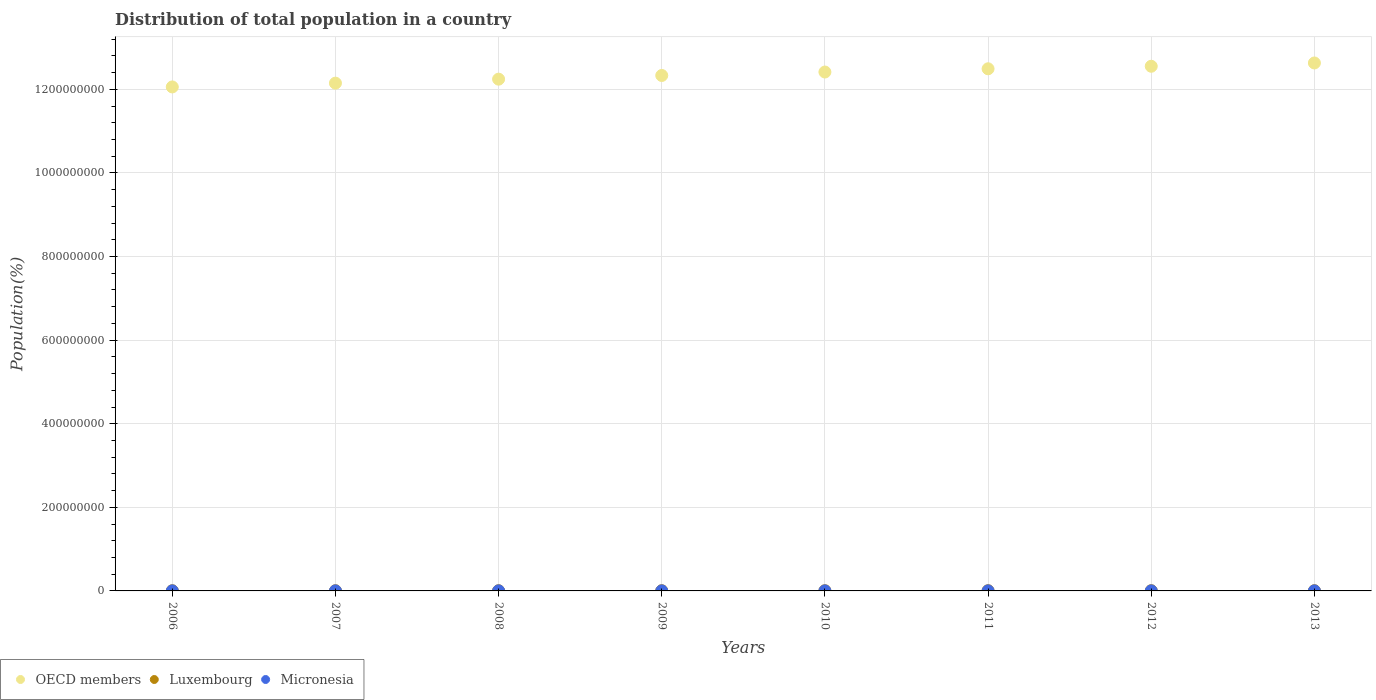How many different coloured dotlines are there?
Your answer should be compact. 3. What is the population of in Micronesia in 2007?
Your answer should be very brief. 1.05e+05. Across all years, what is the maximum population of in Luxembourg?
Your response must be concise. 5.43e+05. Across all years, what is the minimum population of in Micronesia?
Make the answer very short. 1.03e+05. What is the total population of in OECD members in the graph?
Provide a short and direct response. 9.89e+09. What is the difference between the population of in Luxembourg in 2008 and that in 2013?
Offer a very short reply. -5.47e+04. What is the difference between the population of in Micronesia in 2012 and the population of in OECD members in 2008?
Give a very brief answer. -1.22e+09. What is the average population of in Luxembourg per year?
Your answer should be very brief. 5.05e+05. In the year 2011, what is the difference between the population of in Micronesia and population of in OECD members?
Ensure brevity in your answer.  -1.25e+09. In how many years, is the population of in OECD members greater than 120000000 %?
Provide a short and direct response. 8. What is the ratio of the population of in Luxembourg in 2006 to that in 2011?
Offer a terse response. 0.91. What is the difference between the highest and the second highest population of in OECD members?
Give a very brief answer. 7.88e+06. What is the difference between the highest and the lowest population of in Micronesia?
Make the answer very short. 2204. Is the population of in OECD members strictly greater than the population of in Micronesia over the years?
Your answer should be compact. Yes. Is the population of in OECD members strictly less than the population of in Micronesia over the years?
Your answer should be compact. No. How many dotlines are there?
Your response must be concise. 3. Does the graph contain grids?
Your response must be concise. Yes. What is the title of the graph?
Make the answer very short. Distribution of total population in a country. Does "Haiti" appear as one of the legend labels in the graph?
Offer a very short reply. No. What is the label or title of the Y-axis?
Offer a very short reply. Population(%). What is the Population(%) in OECD members in 2006?
Make the answer very short. 1.21e+09. What is the Population(%) of Luxembourg in 2006?
Your answer should be very brief. 4.73e+05. What is the Population(%) of Micronesia in 2006?
Give a very brief answer. 1.06e+05. What is the Population(%) in OECD members in 2007?
Your answer should be very brief. 1.21e+09. What is the Population(%) of Luxembourg in 2007?
Your answer should be very brief. 4.80e+05. What is the Population(%) of Micronesia in 2007?
Offer a terse response. 1.05e+05. What is the Population(%) of OECD members in 2008?
Provide a succinct answer. 1.22e+09. What is the Population(%) in Luxembourg in 2008?
Your response must be concise. 4.89e+05. What is the Population(%) in Micronesia in 2008?
Your answer should be compact. 1.04e+05. What is the Population(%) of OECD members in 2009?
Ensure brevity in your answer.  1.23e+09. What is the Population(%) in Luxembourg in 2009?
Keep it short and to the point. 4.98e+05. What is the Population(%) of Micronesia in 2009?
Your response must be concise. 1.04e+05. What is the Population(%) of OECD members in 2010?
Ensure brevity in your answer.  1.24e+09. What is the Population(%) in Luxembourg in 2010?
Keep it short and to the point. 5.07e+05. What is the Population(%) in Micronesia in 2010?
Keep it short and to the point. 1.04e+05. What is the Population(%) of OECD members in 2011?
Offer a very short reply. 1.25e+09. What is the Population(%) of Luxembourg in 2011?
Provide a succinct answer. 5.18e+05. What is the Population(%) in Micronesia in 2011?
Ensure brevity in your answer.  1.03e+05. What is the Population(%) in OECD members in 2012?
Give a very brief answer. 1.26e+09. What is the Population(%) in Luxembourg in 2012?
Keep it short and to the point. 5.31e+05. What is the Population(%) of Micronesia in 2012?
Give a very brief answer. 1.04e+05. What is the Population(%) of OECD members in 2013?
Provide a succinct answer. 1.26e+09. What is the Population(%) in Luxembourg in 2013?
Keep it short and to the point. 5.43e+05. What is the Population(%) of Micronesia in 2013?
Your answer should be compact. 1.04e+05. Across all years, what is the maximum Population(%) of OECD members?
Offer a terse response. 1.26e+09. Across all years, what is the maximum Population(%) of Luxembourg?
Provide a succinct answer. 5.43e+05. Across all years, what is the maximum Population(%) of Micronesia?
Your answer should be very brief. 1.06e+05. Across all years, what is the minimum Population(%) in OECD members?
Ensure brevity in your answer.  1.21e+09. Across all years, what is the minimum Population(%) in Luxembourg?
Your answer should be compact. 4.73e+05. Across all years, what is the minimum Population(%) in Micronesia?
Offer a very short reply. 1.03e+05. What is the total Population(%) in OECD members in the graph?
Offer a terse response. 9.89e+09. What is the total Population(%) of Luxembourg in the graph?
Provide a short and direct response. 4.04e+06. What is the total Population(%) of Micronesia in the graph?
Provide a succinct answer. 8.34e+05. What is the difference between the Population(%) of OECD members in 2006 and that in 2007?
Offer a terse response. -9.07e+06. What is the difference between the Population(%) of Luxembourg in 2006 and that in 2007?
Offer a very short reply. -7356. What is the difference between the Population(%) of Micronesia in 2006 and that in 2007?
Your response must be concise. 600. What is the difference between the Population(%) in OECD members in 2006 and that in 2008?
Give a very brief answer. -1.86e+07. What is the difference between the Population(%) in Luxembourg in 2006 and that in 2008?
Your answer should be compact. -1.60e+04. What is the difference between the Population(%) of Micronesia in 2006 and that in 2008?
Your response must be concise. 1208. What is the difference between the Population(%) of OECD members in 2006 and that in 2009?
Your answer should be compact. -2.74e+07. What is the difference between the Population(%) of Luxembourg in 2006 and that in 2009?
Offer a very short reply. -2.51e+04. What is the difference between the Population(%) of Micronesia in 2006 and that in 2009?
Ensure brevity in your answer.  1719. What is the difference between the Population(%) of OECD members in 2006 and that in 2010?
Keep it short and to the point. -3.57e+07. What is the difference between the Population(%) of Luxembourg in 2006 and that in 2010?
Make the answer very short. -3.43e+04. What is the difference between the Population(%) in Micronesia in 2006 and that in 2010?
Your answer should be compact. 2061. What is the difference between the Population(%) of OECD members in 2006 and that in 2011?
Give a very brief answer. -4.34e+07. What is the difference between the Population(%) in Luxembourg in 2006 and that in 2011?
Keep it short and to the point. -4.57e+04. What is the difference between the Population(%) in Micronesia in 2006 and that in 2011?
Offer a terse response. 2204. What is the difference between the Population(%) in OECD members in 2006 and that in 2012?
Provide a short and direct response. -4.95e+07. What is the difference between the Population(%) in Luxembourg in 2006 and that in 2012?
Your answer should be very brief. -5.83e+04. What is the difference between the Population(%) of Micronesia in 2006 and that in 2012?
Provide a succinct answer. 2164. What is the difference between the Population(%) in OECD members in 2006 and that in 2013?
Give a very brief answer. -5.73e+07. What is the difference between the Population(%) in Luxembourg in 2006 and that in 2013?
Offer a very short reply. -7.07e+04. What is the difference between the Population(%) in Micronesia in 2006 and that in 2013?
Your response must be concise. 1962. What is the difference between the Population(%) of OECD members in 2007 and that in 2008?
Provide a succinct answer. -9.55e+06. What is the difference between the Population(%) in Luxembourg in 2007 and that in 2008?
Keep it short and to the point. -8657. What is the difference between the Population(%) in Micronesia in 2007 and that in 2008?
Keep it short and to the point. 608. What is the difference between the Population(%) of OECD members in 2007 and that in 2009?
Ensure brevity in your answer.  -1.83e+07. What is the difference between the Population(%) in Luxembourg in 2007 and that in 2009?
Ensure brevity in your answer.  -1.78e+04. What is the difference between the Population(%) of Micronesia in 2007 and that in 2009?
Provide a succinct answer. 1119. What is the difference between the Population(%) in OECD members in 2007 and that in 2010?
Your response must be concise. -2.66e+07. What is the difference between the Population(%) in Luxembourg in 2007 and that in 2010?
Offer a very short reply. -2.70e+04. What is the difference between the Population(%) in Micronesia in 2007 and that in 2010?
Ensure brevity in your answer.  1461. What is the difference between the Population(%) in OECD members in 2007 and that in 2011?
Offer a terse response. -3.43e+07. What is the difference between the Population(%) of Luxembourg in 2007 and that in 2011?
Ensure brevity in your answer.  -3.84e+04. What is the difference between the Population(%) of Micronesia in 2007 and that in 2011?
Provide a short and direct response. 1604. What is the difference between the Population(%) in OECD members in 2007 and that in 2012?
Provide a short and direct response. -4.04e+07. What is the difference between the Population(%) in Luxembourg in 2007 and that in 2012?
Offer a terse response. -5.10e+04. What is the difference between the Population(%) in Micronesia in 2007 and that in 2012?
Offer a terse response. 1564. What is the difference between the Population(%) of OECD members in 2007 and that in 2013?
Keep it short and to the point. -4.83e+07. What is the difference between the Population(%) of Luxembourg in 2007 and that in 2013?
Your answer should be compact. -6.34e+04. What is the difference between the Population(%) in Micronesia in 2007 and that in 2013?
Give a very brief answer. 1362. What is the difference between the Population(%) in OECD members in 2008 and that in 2009?
Make the answer very short. -8.80e+06. What is the difference between the Population(%) in Luxembourg in 2008 and that in 2009?
Offer a terse response. -9133. What is the difference between the Population(%) in Micronesia in 2008 and that in 2009?
Give a very brief answer. 511. What is the difference between the Population(%) in OECD members in 2008 and that in 2010?
Your answer should be compact. -1.71e+07. What is the difference between the Population(%) in Luxembourg in 2008 and that in 2010?
Your answer should be compact. -1.83e+04. What is the difference between the Population(%) of Micronesia in 2008 and that in 2010?
Offer a very short reply. 853. What is the difference between the Population(%) in OECD members in 2008 and that in 2011?
Ensure brevity in your answer.  -2.48e+07. What is the difference between the Population(%) of Luxembourg in 2008 and that in 2011?
Give a very brief answer. -2.97e+04. What is the difference between the Population(%) in Micronesia in 2008 and that in 2011?
Make the answer very short. 996. What is the difference between the Population(%) of OECD members in 2008 and that in 2012?
Offer a terse response. -3.08e+07. What is the difference between the Population(%) of Luxembourg in 2008 and that in 2012?
Make the answer very short. -4.23e+04. What is the difference between the Population(%) of Micronesia in 2008 and that in 2012?
Provide a succinct answer. 956. What is the difference between the Population(%) in OECD members in 2008 and that in 2013?
Give a very brief answer. -3.87e+07. What is the difference between the Population(%) in Luxembourg in 2008 and that in 2013?
Offer a terse response. -5.47e+04. What is the difference between the Population(%) in Micronesia in 2008 and that in 2013?
Provide a short and direct response. 754. What is the difference between the Population(%) in OECD members in 2009 and that in 2010?
Provide a succinct answer. -8.26e+06. What is the difference between the Population(%) in Luxembourg in 2009 and that in 2010?
Ensure brevity in your answer.  -9170. What is the difference between the Population(%) in Micronesia in 2009 and that in 2010?
Give a very brief answer. 342. What is the difference between the Population(%) of OECD members in 2009 and that in 2011?
Keep it short and to the point. -1.60e+07. What is the difference between the Population(%) in Luxembourg in 2009 and that in 2011?
Offer a terse response. -2.06e+04. What is the difference between the Population(%) in Micronesia in 2009 and that in 2011?
Give a very brief answer. 485. What is the difference between the Population(%) in OECD members in 2009 and that in 2012?
Make the answer very short. -2.20e+07. What is the difference between the Population(%) in Luxembourg in 2009 and that in 2012?
Your answer should be compact. -3.32e+04. What is the difference between the Population(%) in Micronesia in 2009 and that in 2012?
Make the answer very short. 445. What is the difference between the Population(%) in OECD members in 2009 and that in 2013?
Provide a succinct answer. -2.99e+07. What is the difference between the Population(%) of Luxembourg in 2009 and that in 2013?
Your answer should be compact. -4.56e+04. What is the difference between the Population(%) of Micronesia in 2009 and that in 2013?
Ensure brevity in your answer.  243. What is the difference between the Population(%) of OECD members in 2010 and that in 2011?
Keep it short and to the point. -7.74e+06. What is the difference between the Population(%) in Luxembourg in 2010 and that in 2011?
Provide a succinct answer. -1.14e+04. What is the difference between the Population(%) in Micronesia in 2010 and that in 2011?
Ensure brevity in your answer.  143. What is the difference between the Population(%) in OECD members in 2010 and that in 2012?
Provide a short and direct response. -1.38e+07. What is the difference between the Population(%) in Luxembourg in 2010 and that in 2012?
Offer a very short reply. -2.40e+04. What is the difference between the Population(%) in Micronesia in 2010 and that in 2012?
Offer a terse response. 103. What is the difference between the Population(%) of OECD members in 2010 and that in 2013?
Provide a succinct answer. -2.17e+07. What is the difference between the Population(%) in Luxembourg in 2010 and that in 2013?
Offer a terse response. -3.64e+04. What is the difference between the Population(%) in Micronesia in 2010 and that in 2013?
Give a very brief answer. -99. What is the difference between the Population(%) of OECD members in 2011 and that in 2012?
Give a very brief answer. -6.05e+06. What is the difference between the Population(%) in Luxembourg in 2011 and that in 2012?
Offer a terse response. -1.26e+04. What is the difference between the Population(%) in OECD members in 2011 and that in 2013?
Your response must be concise. -1.39e+07. What is the difference between the Population(%) in Luxembourg in 2011 and that in 2013?
Provide a short and direct response. -2.50e+04. What is the difference between the Population(%) of Micronesia in 2011 and that in 2013?
Provide a short and direct response. -242. What is the difference between the Population(%) of OECD members in 2012 and that in 2013?
Provide a short and direct response. -7.88e+06. What is the difference between the Population(%) in Luxembourg in 2012 and that in 2013?
Make the answer very short. -1.24e+04. What is the difference between the Population(%) of Micronesia in 2012 and that in 2013?
Make the answer very short. -202. What is the difference between the Population(%) of OECD members in 2006 and the Population(%) of Luxembourg in 2007?
Keep it short and to the point. 1.21e+09. What is the difference between the Population(%) in OECD members in 2006 and the Population(%) in Micronesia in 2007?
Your answer should be compact. 1.21e+09. What is the difference between the Population(%) in Luxembourg in 2006 and the Population(%) in Micronesia in 2007?
Offer a very short reply. 3.68e+05. What is the difference between the Population(%) in OECD members in 2006 and the Population(%) in Luxembourg in 2008?
Provide a succinct answer. 1.21e+09. What is the difference between the Population(%) of OECD members in 2006 and the Population(%) of Micronesia in 2008?
Offer a very short reply. 1.21e+09. What is the difference between the Population(%) in Luxembourg in 2006 and the Population(%) in Micronesia in 2008?
Offer a terse response. 3.68e+05. What is the difference between the Population(%) of OECD members in 2006 and the Population(%) of Luxembourg in 2009?
Ensure brevity in your answer.  1.21e+09. What is the difference between the Population(%) of OECD members in 2006 and the Population(%) of Micronesia in 2009?
Your answer should be very brief. 1.21e+09. What is the difference between the Population(%) in Luxembourg in 2006 and the Population(%) in Micronesia in 2009?
Keep it short and to the point. 3.69e+05. What is the difference between the Population(%) of OECD members in 2006 and the Population(%) of Luxembourg in 2010?
Your response must be concise. 1.21e+09. What is the difference between the Population(%) in OECD members in 2006 and the Population(%) in Micronesia in 2010?
Your response must be concise. 1.21e+09. What is the difference between the Population(%) of Luxembourg in 2006 and the Population(%) of Micronesia in 2010?
Keep it short and to the point. 3.69e+05. What is the difference between the Population(%) of OECD members in 2006 and the Population(%) of Luxembourg in 2011?
Make the answer very short. 1.21e+09. What is the difference between the Population(%) in OECD members in 2006 and the Population(%) in Micronesia in 2011?
Your response must be concise. 1.21e+09. What is the difference between the Population(%) of Luxembourg in 2006 and the Population(%) of Micronesia in 2011?
Offer a very short reply. 3.69e+05. What is the difference between the Population(%) in OECD members in 2006 and the Population(%) in Luxembourg in 2012?
Make the answer very short. 1.21e+09. What is the difference between the Population(%) of OECD members in 2006 and the Population(%) of Micronesia in 2012?
Ensure brevity in your answer.  1.21e+09. What is the difference between the Population(%) of Luxembourg in 2006 and the Population(%) of Micronesia in 2012?
Offer a terse response. 3.69e+05. What is the difference between the Population(%) in OECD members in 2006 and the Population(%) in Luxembourg in 2013?
Your answer should be compact. 1.21e+09. What is the difference between the Population(%) in OECD members in 2006 and the Population(%) in Micronesia in 2013?
Your response must be concise. 1.21e+09. What is the difference between the Population(%) in Luxembourg in 2006 and the Population(%) in Micronesia in 2013?
Provide a short and direct response. 3.69e+05. What is the difference between the Population(%) of OECD members in 2007 and the Population(%) of Luxembourg in 2008?
Make the answer very short. 1.21e+09. What is the difference between the Population(%) in OECD members in 2007 and the Population(%) in Micronesia in 2008?
Make the answer very short. 1.21e+09. What is the difference between the Population(%) of Luxembourg in 2007 and the Population(%) of Micronesia in 2008?
Keep it short and to the point. 3.76e+05. What is the difference between the Population(%) in OECD members in 2007 and the Population(%) in Luxembourg in 2009?
Keep it short and to the point. 1.21e+09. What is the difference between the Population(%) in OECD members in 2007 and the Population(%) in Micronesia in 2009?
Make the answer very short. 1.21e+09. What is the difference between the Population(%) of Luxembourg in 2007 and the Population(%) of Micronesia in 2009?
Keep it short and to the point. 3.76e+05. What is the difference between the Population(%) in OECD members in 2007 and the Population(%) in Luxembourg in 2010?
Offer a terse response. 1.21e+09. What is the difference between the Population(%) of OECD members in 2007 and the Population(%) of Micronesia in 2010?
Ensure brevity in your answer.  1.21e+09. What is the difference between the Population(%) of Luxembourg in 2007 and the Population(%) of Micronesia in 2010?
Provide a short and direct response. 3.76e+05. What is the difference between the Population(%) of OECD members in 2007 and the Population(%) of Luxembourg in 2011?
Ensure brevity in your answer.  1.21e+09. What is the difference between the Population(%) of OECD members in 2007 and the Population(%) of Micronesia in 2011?
Offer a terse response. 1.21e+09. What is the difference between the Population(%) in Luxembourg in 2007 and the Population(%) in Micronesia in 2011?
Ensure brevity in your answer.  3.77e+05. What is the difference between the Population(%) of OECD members in 2007 and the Population(%) of Luxembourg in 2012?
Make the answer very short. 1.21e+09. What is the difference between the Population(%) of OECD members in 2007 and the Population(%) of Micronesia in 2012?
Keep it short and to the point. 1.21e+09. What is the difference between the Population(%) of Luxembourg in 2007 and the Population(%) of Micronesia in 2012?
Offer a very short reply. 3.76e+05. What is the difference between the Population(%) in OECD members in 2007 and the Population(%) in Luxembourg in 2013?
Ensure brevity in your answer.  1.21e+09. What is the difference between the Population(%) in OECD members in 2007 and the Population(%) in Micronesia in 2013?
Provide a short and direct response. 1.21e+09. What is the difference between the Population(%) of Luxembourg in 2007 and the Population(%) of Micronesia in 2013?
Provide a short and direct response. 3.76e+05. What is the difference between the Population(%) of OECD members in 2008 and the Population(%) of Luxembourg in 2009?
Give a very brief answer. 1.22e+09. What is the difference between the Population(%) of OECD members in 2008 and the Population(%) of Micronesia in 2009?
Keep it short and to the point. 1.22e+09. What is the difference between the Population(%) of Luxembourg in 2008 and the Population(%) of Micronesia in 2009?
Offer a terse response. 3.85e+05. What is the difference between the Population(%) in OECD members in 2008 and the Population(%) in Luxembourg in 2010?
Give a very brief answer. 1.22e+09. What is the difference between the Population(%) of OECD members in 2008 and the Population(%) of Micronesia in 2010?
Your response must be concise. 1.22e+09. What is the difference between the Population(%) of Luxembourg in 2008 and the Population(%) of Micronesia in 2010?
Provide a short and direct response. 3.85e+05. What is the difference between the Population(%) of OECD members in 2008 and the Population(%) of Luxembourg in 2011?
Offer a very short reply. 1.22e+09. What is the difference between the Population(%) in OECD members in 2008 and the Population(%) in Micronesia in 2011?
Your response must be concise. 1.22e+09. What is the difference between the Population(%) of Luxembourg in 2008 and the Population(%) of Micronesia in 2011?
Give a very brief answer. 3.85e+05. What is the difference between the Population(%) in OECD members in 2008 and the Population(%) in Luxembourg in 2012?
Offer a very short reply. 1.22e+09. What is the difference between the Population(%) of OECD members in 2008 and the Population(%) of Micronesia in 2012?
Your answer should be very brief. 1.22e+09. What is the difference between the Population(%) in Luxembourg in 2008 and the Population(%) in Micronesia in 2012?
Offer a very short reply. 3.85e+05. What is the difference between the Population(%) of OECD members in 2008 and the Population(%) of Luxembourg in 2013?
Provide a short and direct response. 1.22e+09. What is the difference between the Population(%) of OECD members in 2008 and the Population(%) of Micronesia in 2013?
Your response must be concise. 1.22e+09. What is the difference between the Population(%) in Luxembourg in 2008 and the Population(%) in Micronesia in 2013?
Your answer should be very brief. 3.85e+05. What is the difference between the Population(%) of OECD members in 2009 and the Population(%) of Luxembourg in 2010?
Your answer should be compact. 1.23e+09. What is the difference between the Population(%) in OECD members in 2009 and the Population(%) in Micronesia in 2010?
Your answer should be very brief. 1.23e+09. What is the difference between the Population(%) of Luxembourg in 2009 and the Population(%) of Micronesia in 2010?
Your answer should be very brief. 3.94e+05. What is the difference between the Population(%) of OECD members in 2009 and the Population(%) of Luxembourg in 2011?
Provide a short and direct response. 1.23e+09. What is the difference between the Population(%) of OECD members in 2009 and the Population(%) of Micronesia in 2011?
Give a very brief answer. 1.23e+09. What is the difference between the Population(%) of Luxembourg in 2009 and the Population(%) of Micronesia in 2011?
Your response must be concise. 3.94e+05. What is the difference between the Population(%) in OECD members in 2009 and the Population(%) in Luxembourg in 2012?
Offer a terse response. 1.23e+09. What is the difference between the Population(%) of OECD members in 2009 and the Population(%) of Micronesia in 2012?
Give a very brief answer. 1.23e+09. What is the difference between the Population(%) of Luxembourg in 2009 and the Population(%) of Micronesia in 2012?
Your answer should be very brief. 3.94e+05. What is the difference between the Population(%) of OECD members in 2009 and the Population(%) of Luxembourg in 2013?
Keep it short and to the point. 1.23e+09. What is the difference between the Population(%) of OECD members in 2009 and the Population(%) of Micronesia in 2013?
Make the answer very short. 1.23e+09. What is the difference between the Population(%) in Luxembourg in 2009 and the Population(%) in Micronesia in 2013?
Offer a very short reply. 3.94e+05. What is the difference between the Population(%) in OECD members in 2010 and the Population(%) in Luxembourg in 2011?
Provide a short and direct response. 1.24e+09. What is the difference between the Population(%) in OECD members in 2010 and the Population(%) in Micronesia in 2011?
Your answer should be very brief. 1.24e+09. What is the difference between the Population(%) in Luxembourg in 2010 and the Population(%) in Micronesia in 2011?
Provide a short and direct response. 4.03e+05. What is the difference between the Population(%) of OECD members in 2010 and the Population(%) of Luxembourg in 2012?
Offer a very short reply. 1.24e+09. What is the difference between the Population(%) in OECD members in 2010 and the Population(%) in Micronesia in 2012?
Provide a short and direct response. 1.24e+09. What is the difference between the Population(%) of Luxembourg in 2010 and the Population(%) of Micronesia in 2012?
Your answer should be compact. 4.03e+05. What is the difference between the Population(%) of OECD members in 2010 and the Population(%) of Luxembourg in 2013?
Give a very brief answer. 1.24e+09. What is the difference between the Population(%) in OECD members in 2010 and the Population(%) in Micronesia in 2013?
Offer a terse response. 1.24e+09. What is the difference between the Population(%) in Luxembourg in 2010 and the Population(%) in Micronesia in 2013?
Make the answer very short. 4.03e+05. What is the difference between the Population(%) in OECD members in 2011 and the Population(%) in Luxembourg in 2012?
Offer a very short reply. 1.25e+09. What is the difference between the Population(%) in OECD members in 2011 and the Population(%) in Micronesia in 2012?
Your answer should be compact. 1.25e+09. What is the difference between the Population(%) in Luxembourg in 2011 and the Population(%) in Micronesia in 2012?
Provide a short and direct response. 4.15e+05. What is the difference between the Population(%) in OECD members in 2011 and the Population(%) in Luxembourg in 2013?
Ensure brevity in your answer.  1.25e+09. What is the difference between the Population(%) of OECD members in 2011 and the Population(%) of Micronesia in 2013?
Offer a terse response. 1.25e+09. What is the difference between the Population(%) of Luxembourg in 2011 and the Population(%) of Micronesia in 2013?
Make the answer very short. 4.15e+05. What is the difference between the Population(%) of OECD members in 2012 and the Population(%) of Luxembourg in 2013?
Provide a short and direct response. 1.25e+09. What is the difference between the Population(%) of OECD members in 2012 and the Population(%) of Micronesia in 2013?
Offer a very short reply. 1.26e+09. What is the difference between the Population(%) in Luxembourg in 2012 and the Population(%) in Micronesia in 2013?
Offer a terse response. 4.27e+05. What is the average Population(%) in OECD members per year?
Offer a very short reply. 1.24e+09. What is the average Population(%) of Luxembourg per year?
Your answer should be very brief. 5.05e+05. What is the average Population(%) in Micronesia per year?
Make the answer very short. 1.04e+05. In the year 2006, what is the difference between the Population(%) of OECD members and Population(%) of Luxembourg?
Your response must be concise. 1.21e+09. In the year 2006, what is the difference between the Population(%) in OECD members and Population(%) in Micronesia?
Keep it short and to the point. 1.21e+09. In the year 2006, what is the difference between the Population(%) in Luxembourg and Population(%) in Micronesia?
Ensure brevity in your answer.  3.67e+05. In the year 2007, what is the difference between the Population(%) in OECD members and Population(%) in Luxembourg?
Provide a succinct answer. 1.21e+09. In the year 2007, what is the difference between the Population(%) of OECD members and Population(%) of Micronesia?
Make the answer very short. 1.21e+09. In the year 2007, what is the difference between the Population(%) in Luxembourg and Population(%) in Micronesia?
Your answer should be compact. 3.75e+05. In the year 2008, what is the difference between the Population(%) of OECD members and Population(%) of Luxembourg?
Offer a terse response. 1.22e+09. In the year 2008, what is the difference between the Population(%) of OECD members and Population(%) of Micronesia?
Ensure brevity in your answer.  1.22e+09. In the year 2008, what is the difference between the Population(%) in Luxembourg and Population(%) in Micronesia?
Ensure brevity in your answer.  3.84e+05. In the year 2009, what is the difference between the Population(%) of OECD members and Population(%) of Luxembourg?
Make the answer very short. 1.23e+09. In the year 2009, what is the difference between the Population(%) in OECD members and Population(%) in Micronesia?
Make the answer very short. 1.23e+09. In the year 2009, what is the difference between the Population(%) in Luxembourg and Population(%) in Micronesia?
Your answer should be very brief. 3.94e+05. In the year 2010, what is the difference between the Population(%) in OECD members and Population(%) in Luxembourg?
Ensure brevity in your answer.  1.24e+09. In the year 2010, what is the difference between the Population(%) of OECD members and Population(%) of Micronesia?
Ensure brevity in your answer.  1.24e+09. In the year 2010, what is the difference between the Population(%) of Luxembourg and Population(%) of Micronesia?
Your response must be concise. 4.03e+05. In the year 2011, what is the difference between the Population(%) in OECD members and Population(%) in Luxembourg?
Make the answer very short. 1.25e+09. In the year 2011, what is the difference between the Population(%) of OECD members and Population(%) of Micronesia?
Give a very brief answer. 1.25e+09. In the year 2011, what is the difference between the Population(%) of Luxembourg and Population(%) of Micronesia?
Offer a terse response. 4.15e+05. In the year 2012, what is the difference between the Population(%) of OECD members and Population(%) of Luxembourg?
Your answer should be compact. 1.25e+09. In the year 2012, what is the difference between the Population(%) in OECD members and Population(%) in Micronesia?
Provide a short and direct response. 1.26e+09. In the year 2012, what is the difference between the Population(%) in Luxembourg and Population(%) in Micronesia?
Ensure brevity in your answer.  4.27e+05. In the year 2013, what is the difference between the Population(%) of OECD members and Population(%) of Luxembourg?
Your answer should be very brief. 1.26e+09. In the year 2013, what is the difference between the Population(%) of OECD members and Population(%) of Micronesia?
Offer a very short reply. 1.26e+09. In the year 2013, what is the difference between the Population(%) of Luxembourg and Population(%) of Micronesia?
Offer a terse response. 4.40e+05. What is the ratio of the Population(%) of Luxembourg in 2006 to that in 2007?
Your answer should be very brief. 0.98. What is the ratio of the Population(%) in OECD members in 2006 to that in 2008?
Provide a succinct answer. 0.98. What is the ratio of the Population(%) of Luxembourg in 2006 to that in 2008?
Make the answer very short. 0.97. What is the ratio of the Population(%) in Micronesia in 2006 to that in 2008?
Your response must be concise. 1.01. What is the ratio of the Population(%) in OECD members in 2006 to that in 2009?
Your response must be concise. 0.98. What is the ratio of the Population(%) of Luxembourg in 2006 to that in 2009?
Provide a short and direct response. 0.95. What is the ratio of the Population(%) in Micronesia in 2006 to that in 2009?
Ensure brevity in your answer.  1.02. What is the ratio of the Population(%) of OECD members in 2006 to that in 2010?
Make the answer very short. 0.97. What is the ratio of the Population(%) in Luxembourg in 2006 to that in 2010?
Offer a terse response. 0.93. What is the ratio of the Population(%) of Micronesia in 2006 to that in 2010?
Provide a short and direct response. 1.02. What is the ratio of the Population(%) of OECD members in 2006 to that in 2011?
Provide a short and direct response. 0.97. What is the ratio of the Population(%) of Luxembourg in 2006 to that in 2011?
Offer a very short reply. 0.91. What is the ratio of the Population(%) in Micronesia in 2006 to that in 2011?
Make the answer very short. 1.02. What is the ratio of the Population(%) in OECD members in 2006 to that in 2012?
Your response must be concise. 0.96. What is the ratio of the Population(%) of Luxembourg in 2006 to that in 2012?
Ensure brevity in your answer.  0.89. What is the ratio of the Population(%) in Micronesia in 2006 to that in 2012?
Offer a very short reply. 1.02. What is the ratio of the Population(%) in OECD members in 2006 to that in 2013?
Offer a very short reply. 0.95. What is the ratio of the Population(%) in Luxembourg in 2006 to that in 2013?
Your answer should be compact. 0.87. What is the ratio of the Population(%) of Micronesia in 2006 to that in 2013?
Offer a very short reply. 1.02. What is the ratio of the Population(%) of OECD members in 2007 to that in 2008?
Keep it short and to the point. 0.99. What is the ratio of the Population(%) of Luxembourg in 2007 to that in 2008?
Your answer should be very brief. 0.98. What is the ratio of the Population(%) in Micronesia in 2007 to that in 2008?
Provide a short and direct response. 1.01. What is the ratio of the Population(%) in OECD members in 2007 to that in 2009?
Your answer should be compact. 0.99. What is the ratio of the Population(%) in Luxembourg in 2007 to that in 2009?
Give a very brief answer. 0.96. What is the ratio of the Population(%) of Micronesia in 2007 to that in 2009?
Offer a terse response. 1.01. What is the ratio of the Population(%) of OECD members in 2007 to that in 2010?
Your response must be concise. 0.98. What is the ratio of the Population(%) in Luxembourg in 2007 to that in 2010?
Your answer should be compact. 0.95. What is the ratio of the Population(%) in Micronesia in 2007 to that in 2010?
Provide a succinct answer. 1.01. What is the ratio of the Population(%) of OECD members in 2007 to that in 2011?
Keep it short and to the point. 0.97. What is the ratio of the Population(%) of Luxembourg in 2007 to that in 2011?
Ensure brevity in your answer.  0.93. What is the ratio of the Population(%) in Micronesia in 2007 to that in 2011?
Provide a short and direct response. 1.02. What is the ratio of the Population(%) in OECD members in 2007 to that in 2012?
Your answer should be very brief. 0.97. What is the ratio of the Population(%) in Luxembourg in 2007 to that in 2012?
Offer a very short reply. 0.9. What is the ratio of the Population(%) of Micronesia in 2007 to that in 2012?
Your answer should be very brief. 1.02. What is the ratio of the Population(%) in OECD members in 2007 to that in 2013?
Your response must be concise. 0.96. What is the ratio of the Population(%) in Luxembourg in 2007 to that in 2013?
Give a very brief answer. 0.88. What is the ratio of the Population(%) of Micronesia in 2007 to that in 2013?
Offer a very short reply. 1.01. What is the ratio of the Population(%) of OECD members in 2008 to that in 2009?
Offer a terse response. 0.99. What is the ratio of the Population(%) in Luxembourg in 2008 to that in 2009?
Your answer should be very brief. 0.98. What is the ratio of the Population(%) of Micronesia in 2008 to that in 2009?
Keep it short and to the point. 1. What is the ratio of the Population(%) of OECD members in 2008 to that in 2010?
Keep it short and to the point. 0.99. What is the ratio of the Population(%) in Luxembourg in 2008 to that in 2010?
Provide a succinct answer. 0.96. What is the ratio of the Population(%) of Micronesia in 2008 to that in 2010?
Offer a very short reply. 1.01. What is the ratio of the Population(%) in OECD members in 2008 to that in 2011?
Offer a very short reply. 0.98. What is the ratio of the Population(%) of Luxembourg in 2008 to that in 2011?
Give a very brief answer. 0.94. What is the ratio of the Population(%) in Micronesia in 2008 to that in 2011?
Offer a terse response. 1.01. What is the ratio of the Population(%) in OECD members in 2008 to that in 2012?
Offer a terse response. 0.98. What is the ratio of the Population(%) of Luxembourg in 2008 to that in 2012?
Give a very brief answer. 0.92. What is the ratio of the Population(%) of Micronesia in 2008 to that in 2012?
Offer a very short reply. 1.01. What is the ratio of the Population(%) in OECD members in 2008 to that in 2013?
Offer a terse response. 0.97. What is the ratio of the Population(%) of Luxembourg in 2008 to that in 2013?
Ensure brevity in your answer.  0.9. What is the ratio of the Population(%) in Micronesia in 2008 to that in 2013?
Offer a very short reply. 1.01. What is the ratio of the Population(%) in Luxembourg in 2009 to that in 2010?
Provide a succinct answer. 0.98. What is the ratio of the Population(%) of OECD members in 2009 to that in 2011?
Your answer should be compact. 0.99. What is the ratio of the Population(%) in Luxembourg in 2009 to that in 2011?
Keep it short and to the point. 0.96. What is the ratio of the Population(%) in OECD members in 2009 to that in 2012?
Provide a short and direct response. 0.98. What is the ratio of the Population(%) in Luxembourg in 2009 to that in 2012?
Provide a short and direct response. 0.94. What is the ratio of the Population(%) in Micronesia in 2009 to that in 2012?
Provide a succinct answer. 1. What is the ratio of the Population(%) of OECD members in 2009 to that in 2013?
Keep it short and to the point. 0.98. What is the ratio of the Population(%) in Luxembourg in 2009 to that in 2013?
Keep it short and to the point. 0.92. What is the ratio of the Population(%) in Micronesia in 2010 to that in 2011?
Your response must be concise. 1. What is the ratio of the Population(%) of Luxembourg in 2010 to that in 2012?
Offer a terse response. 0.95. What is the ratio of the Population(%) in Micronesia in 2010 to that in 2012?
Your answer should be compact. 1. What is the ratio of the Population(%) in OECD members in 2010 to that in 2013?
Keep it short and to the point. 0.98. What is the ratio of the Population(%) of Luxembourg in 2010 to that in 2013?
Your response must be concise. 0.93. What is the ratio of the Population(%) of Micronesia in 2010 to that in 2013?
Ensure brevity in your answer.  1. What is the ratio of the Population(%) of OECD members in 2011 to that in 2012?
Offer a very short reply. 1. What is the ratio of the Population(%) in Luxembourg in 2011 to that in 2012?
Keep it short and to the point. 0.98. What is the ratio of the Population(%) of Luxembourg in 2011 to that in 2013?
Your answer should be compact. 0.95. What is the ratio of the Population(%) in Micronesia in 2011 to that in 2013?
Offer a terse response. 1. What is the ratio of the Population(%) of Luxembourg in 2012 to that in 2013?
Keep it short and to the point. 0.98. What is the ratio of the Population(%) of Micronesia in 2012 to that in 2013?
Keep it short and to the point. 1. What is the difference between the highest and the second highest Population(%) in OECD members?
Your response must be concise. 7.88e+06. What is the difference between the highest and the second highest Population(%) of Luxembourg?
Provide a short and direct response. 1.24e+04. What is the difference between the highest and the second highest Population(%) in Micronesia?
Ensure brevity in your answer.  600. What is the difference between the highest and the lowest Population(%) in OECD members?
Provide a succinct answer. 5.73e+07. What is the difference between the highest and the lowest Population(%) of Luxembourg?
Keep it short and to the point. 7.07e+04. What is the difference between the highest and the lowest Population(%) in Micronesia?
Provide a short and direct response. 2204. 